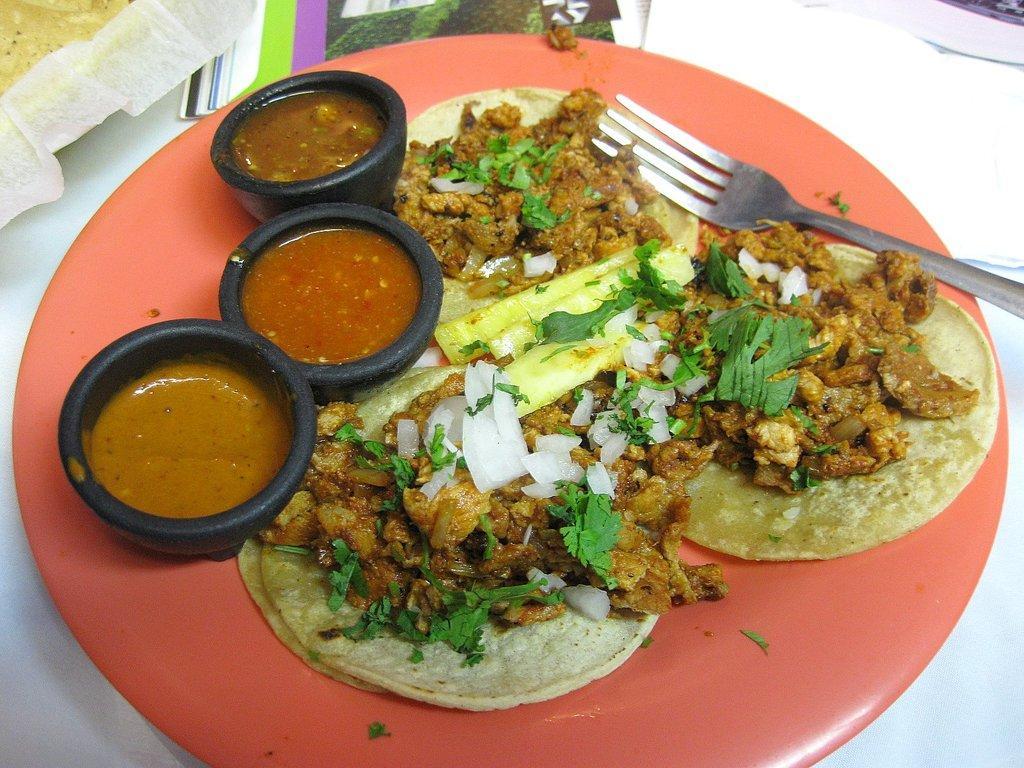Can you describe this image briefly? In this image we can see some food items on the plate, also we can see a spoon, there are some other food item in cups, there are paper napkins, which are on the white colored surface. 